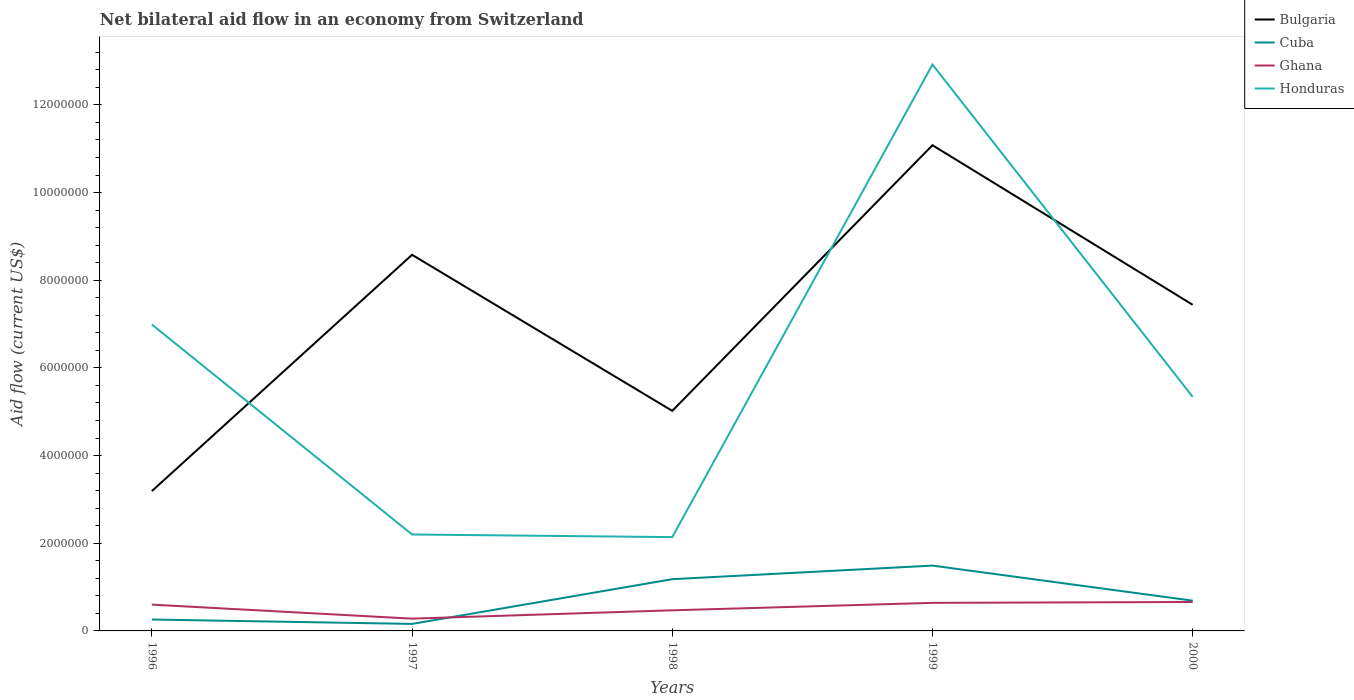How many different coloured lines are there?
Your response must be concise. 4. Does the line corresponding to Bulgaria intersect with the line corresponding to Ghana?
Provide a succinct answer. No. Is the number of lines equal to the number of legend labels?
Keep it short and to the point. Yes. Across all years, what is the maximum net bilateral aid flow in Honduras?
Provide a succinct answer. 2.14e+06. In which year was the net bilateral aid flow in Ghana maximum?
Provide a short and direct response. 1997. What is the total net bilateral aid flow in Cuba in the graph?
Offer a very short reply. -4.30e+05. What is the difference between the highest and the second highest net bilateral aid flow in Cuba?
Keep it short and to the point. 1.33e+06. What is the difference between the highest and the lowest net bilateral aid flow in Cuba?
Make the answer very short. 2. How many lines are there?
Make the answer very short. 4. How many years are there in the graph?
Your response must be concise. 5. Are the values on the major ticks of Y-axis written in scientific E-notation?
Offer a very short reply. No. Does the graph contain any zero values?
Your answer should be very brief. No. Where does the legend appear in the graph?
Your response must be concise. Top right. How are the legend labels stacked?
Make the answer very short. Vertical. What is the title of the graph?
Offer a very short reply. Net bilateral aid flow in an economy from Switzerland. What is the label or title of the X-axis?
Your response must be concise. Years. What is the label or title of the Y-axis?
Make the answer very short. Aid flow (current US$). What is the Aid flow (current US$) in Bulgaria in 1996?
Offer a terse response. 3.19e+06. What is the Aid flow (current US$) in Cuba in 1996?
Provide a short and direct response. 2.60e+05. What is the Aid flow (current US$) of Honduras in 1996?
Keep it short and to the point. 6.99e+06. What is the Aid flow (current US$) of Bulgaria in 1997?
Your answer should be compact. 8.58e+06. What is the Aid flow (current US$) in Ghana in 1997?
Offer a terse response. 2.80e+05. What is the Aid flow (current US$) of Honduras in 1997?
Your answer should be very brief. 2.20e+06. What is the Aid flow (current US$) in Bulgaria in 1998?
Your answer should be compact. 5.02e+06. What is the Aid flow (current US$) in Cuba in 1998?
Your response must be concise. 1.18e+06. What is the Aid flow (current US$) of Honduras in 1998?
Your answer should be compact. 2.14e+06. What is the Aid flow (current US$) of Bulgaria in 1999?
Provide a succinct answer. 1.11e+07. What is the Aid flow (current US$) in Cuba in 1999?
Your response must be concise. 1.49e+06. What is the Aid flow (current US$) in Ghana in 1999?
Keep it short and to the point. 6.40e+05. What is the Aid flow (current US$) of Honduras in 1999?
Keep it short and to the point. 1.29e+07. What is the Aid flow (current US$) in Bulgaria in 2000?
Give a very brief answer. 7.44e+06. What is the Aid flow (current US$) in Cuba in 2000?
Your answer should be compact. 6.90e+05. What is the Aid flow (current US$) of Honduras in 2000?
Offer a very short reply. 5.34e+06. Across all years, what is the maximum Aid flow (current US$) of Bulgaria?
Provide a succinct answer. 1.11e+07. Across all years, what is the maximum Aid flow (current US$) of Cuba?
Your response must be concise. 1.49e+06. Across all years, what is the maximum Aid flow (current US$) in Honduras?
Provide a succinct answer. 1.29e+07. Across all years, what is the minimum Aid flow (current US$) of Bulgaria?
Your answer should be compact. 3.19e+06. Across all years, what is the minimum Aid flow (current US$) in Cuba?
Provide a short and direct response. 1.60e+05. Across all years, what is the minimum Aid flow (current US$) of Ghana?
Provide a short and direct response. 2.80e+05. Across all years, what is the minimum Aid flow (current US$) of Honduras?
Your answer should be compact. 2.14e+06. What is the total Aid flow (current US$) in Bulgaria in the graph?
Keep it short and to the point. 3.53e+07. What is the total Aid flow (current US$) in Cuba in the graph?
Your answer should be very brief. 3.78e+06. What is the total Aid flow (current US$) of Ghana in the graph?
Ensure brevity in your answer.  2.65e+06. What is the total Aid flow (current US$) in Honduras in the graph?
Offer a terse response. 2.96e+07. What is the difference between the Aid flow (current US$) of Bulgaria in 1996 and that in 1997?
Ensure brevity in your answer.  -5.39e+06. What is the difference between the Aid flow (current US$) in Ghana in 1996 and that in 1997?
Offer a terse response. 3.20e+05. What is the difference between the Aid flow (current US$) in Honduras in 1996 and that in 1997?
Your answer should be very brief. 4.79e+06. What is the difference between the Aid flow (current US$) of Bulgaria in 1996 and that in 1998?
Keep it short and to the point. -1.83e+06. What is the difference between the Aid flow (current US$) in Cuba in 1996 and that in 1998?
Your response must be concise. -9.20e+05. What is the difference between the Aid flow (current US$) of Ghana in 1996 and that in 1998?
Offer a terse response. 1.30e+05. What is the difference between the Aid flow (current US$) of Honduras in 1996 and that in 1998?
Offer a very short reply. 4.85e+06. What is the difference between the Aid flow (current US$) in Bulgaria in 1996 and that in 1999?
Provide a short and direct response. -7.89e+06. What is the difference between the Aid flow (current US$) of Cuba in 1996 and that in 1999?
Your response must be concise. -1.23e+06. What is the difference between the Aid flow (current US$) in Ghana in 1996 and that in 1999?
Your response must be concise. -4.00e+04. What is the difference between the Aid flow (current US$) of Honduras in 1996 and that in 1999?
Offer a terse response. -5.93e+06. What is the difference between the Aid flow (current US$) in Bulgaria in 1996 and that in 2000?
Ensure brevity in your answer.  -4.25e+06. What is the difference between the Aid flow (current US$) of Cuba in 1996 and that in 2000?
Your answer should be compact. -4.30e+05. What is the difference between the Aid flow (current US$) in Honduras in 1996 and that in 2000?
Give a very brief answer. 1.65e+06. What is the difference between the Aid flow (current US$) in Bulgaria in 1997 and that in 1998?
Ensure brevity in your answer.  3.56e+06. What is the difference between the Aid flow (current US$) in Cuba in 1997 and that in 1998?
Offer a terse response. -1.02e+06. What is the difference between the Aid flow (current US$) of Ghana in 1997 and that in 1998?
Provide a succinct answer. -1.90e+05. What is the difference between the Aid flow (current US$) in Bulgaria in 1997 and that in 1999?
Make the answer very short. -2.50e+06. What is the difference between the Aid flow (current US$) in Cuba in 1997 and that in 1999?
Your answer should be compact. -1.33e+06. What is the difference between the Aid flow (current US$) in Ghana in 1997 and that in 1999?
Keep it short and to the point. -3.60e+05. What is the difference between the Aid flow (current US$) of Honduras in 1997 and that in 1999?
Keep it short and to the point. -1.07e+07. What is the difference between the Aid flow (current US$) of Bulgaria in 1997 and that in 2000?
Keep it short and to the point. 1.14e+06. What is the difference between the Aid flow (current US$) in Cuba in 1997 and that in 2000?
Give a very brief answer. -5.30e+05. What is the difference between the Aid flow (current US$) of Ghana in 1997 and that in 2000?
Your response must be concise. -3.80e+05. What is the difference between the Aid flow (current US$) of Honduras in 1997 and that in 2000?
Your answer should be very brief. -3.14e+06. What is the difference between the Aid flow (current US$) of Bulgaria in 1998 and that in 1999?
Your answer should be very brief. -6.06e+06. What is the difference between the Aid flow (current US$) of Cuba in 1998 and that in 1999?
Ensure brevity in your answer.  -3.10e+05. What is the difference between the Aid flow (current US$) of Honduras in 1998 and that in 1999?
Your answer should be compact. -1.08e+07. What is the difference between the Aid flow (current US$) of Bulgaria in 1998 and that in 2000?
Your answer should be very brief. -2.42e+06. What is the difference between the Aid flow (current US$) of Honduras in 1998 and that in 2000?
Keep it short and to the point. -3.20e+06. What is the difference between the Aid flow (current US$) of Bulgaria in 1999 and that in 2000?
Offer a terse response. 3.64e+06. What is the difference between the Aid flow (current US$) of Ghana in 1999 and that in 2000?
Provide a short and direct response. -2.00e+04. What is the difference between the Aid flow (current US$) in Honduras in 1999 and that in 2000?
Provide a succinct answer. 7.58e+06. What is the difference between the Aid flow (current US$) of Bulgaria in 1996 and the Aid flow (current US$) of Cuba in 1997?
Provide a short and direct response. 3.03e+06. What is the difference between the Aid flow (current US$) of Bulgaria in 1996 and the Aid flow (current US$) of Ghana in 1997?
Make the answer very short. 2.91e+06. What is the difference between the Aid flow (current US$) in Bulgaria in 1996 and the Aid flow (current US$) in Honduras in 1997?
Your answer should be very brief. 9.90e+05. What is the difference between the Aid flow (current US$) in Cuba in 1996 and the Aid flow (current US$) in Ghana in 1997?
Provide a succinct answer. -2.00e+04. What is the difference between the Aid flow (current US$) in Cuba in 1996 and the Aid flow (current US$) in Honduras in 1997?
Make the answer very short. -1.94e+06. What is the difference between the Aid flow (current US$) of Ghana in 1996 and the Aid flow (current US$) of Honduras in 1997?
Ensure brevity in your answer.  -1.60e+06. What is the difference between the Aid flow (current US$) in Bulgaria in 1996 and the Aid flow (current US$) in Cuba in 1998?
Keep it short and to the point. 2.01e+06. What is the difference between the Aid flow (current US$) in Bulgaria in 1996 and the Aid flow (current US$) in Ghana in 1998?
Your answer should be compact. 2.72e+06. What is the difference between the Aid flow (current US$) of Bulgaria in 1996 and the Aid flow (current US$) of Honduras in 1998?
Your answer should be very brief. 1.05e+06. What is the difference between the Aid flow (current US$) of Cuba in 1996 and the Aid flow (current US$) of Ghana in 1998?
Provide a succinct answer. -2.10e+05. What is the difference between the Aid flow (current US$) of Cuba in 1996 and the Aid flow (current US$) of Honduras in 1998?
Offer a terse response. -1.88e+06. What is the difference between the Aid flow (current US$) of Ghana in 1996 and the Aid flow (current US$) of Honduras in 1998?
Make the answer very short. -1.54e+06. What is the difference between the Aid flow (current US$) in Bulgaria in 1996 and the Aid flow (current US$) in Cuba in 1999?
Offer a very short reply. 1.70e+06. What is the difference between the Aid flow (current US$) of Bulgaria in 1996 and the Aid flow (current US$) of Ghana in 1999?
Provide a short and direct response. 2.55e+06. What is the difference between the Aid flow (current US$) of Bulgaria in 1996 and the Aid flow (current US$) of Honduras in 1999?
Your answer should be very brief. -9.73e+06. What is the difference between the Aid flow (current US$) in Cuba in 1996 and the Aid flow (current US$) in Ghana in 1999?
Your response must be concise. -3.80e+05. What is the difference between the Aid flow (current US$) of Cuba in 1996 and the Aid flow (current US$) of Honduras in 1999?
Provide a short and direct response. -1.27e+07. What is the difference between the Aid flow (current US$) of Ghana in 1996 and the Aid flow (current US$) of Honduras in 1999?
Offer a terse response. -1.23e+07. What is the difference between the Aid flow (current US$) of Bulgaria in 1996 and the Aid flow (current US$) of Cuba in 2000?
Your response must be concise. 2.50e+06. What is the difference between the Aid flow (current US$) in Bulgaria in 1996 and the Aid flow (current US$) in Ghana in 2000?
Offer a terse response. 2.53e+06. What is the difference between the Aid flow (current US$) in Bulgaria in 1996 and the Aid flow (current US$) in Honduras in 2000?
Provide a succinct answer. -2.15e+06. What is the difference between the Aid flow (current US$) of Cuba in 1996 and the Aid flow (current US$) of Ghana in 2000?
Provide a succinct answer. -4.00e+05. What is the difference between the Aid flow (current US$) of Cuba in 1996 and the Aid flow (current US$) of Honduras in 2000?
Give a very brief answer. -5.08e+06. What is the difference between the Aid flow (current US$) in Ghana in 1996 and the Aid flow (current US$) in Honduras in 2000?
Offer a terse response. -4.74e+06. What is the difference between the Aid flow (current US$) in Bulgaria in 1997 and the Aid flow (current US$) in Cuba in 1998?
Your answer should be compact. 7.40e+06. What is the difference between the Aid flow (current US$) of Bulgaria in 1997 and the Aid flow (current US$) of Ghana in 1998?
Give a very brief answer. 8.11e+06. What is the difference between the Aid flow (current US$) of Bulgaria in 1997 and the Aid flow (current US$) of Honduras in 1998?
Provide a succinct answer. 6.44e+06. What is the difference between the Aid flow (current US$) of Cuba in 1997 and the Aid flow (current US$) of Ghana in 1998?
Make the answer very short. -3.10e+05. What is the difference between the Aid flow (current US$) in Cuba in 1997 and the Aid flow (current US$) in Honduras in 1998?
Your response must be concise. -1.98e+06. What is the difference between the Aid flow (current US$) of Ghana in 1997 and the Aid flow (current US$) of Honduras in 1998?
Offer a terse response. -1.86e+06. What is the difference between the Aid flow (current US$) in Bulgaria in 1997 and the Aid flow (current US$) in Cuba in 1999?
Your answer should be compact. 7.09e+06. What is the difference between the Aid flow (current US$) in Bulgaria in 1997 and the Aid flow (current US$) in Ghana in 1999?
Ensure brevity in your answer.  7.94e+06. What is the difference between the Aid flow (current US$) in Bulgaria in 1997 and the Aid flow (current US$) in Honduras in 1999?
Give a very brief answer. -4.34e+06. What is the difference between the Aid flow (current US$) of Cuba in 1997 and the Aid flow (current US$) of Ghana in 1999?
Your answer should be very brief. -4.80e+05. What is the difference between the Aid flow (current US$) of Cuba in 1997 and the Aid flow (current US$) of Honduras in 1999?
Offer a very short reply. -1.28e+07. What is the difference between the Aid flow (current US$) in Ghana in 1997 and the Aid flow (current US$) in Honduras in 1999?
Provide a short and direct response. -1.26e+07. What is the difference between the Aid flow (current US$) of Bulgaria in 1997 and the Aid flow (current US$) of Cuba in 2000?
Ensure brevity in your answer.  7.89e+06. What is the difference between the Aid flow (current US$) of Bulgaria in 1997 and the Aid flow (current US$) of Ghana in 2000?
Offer a very short reply. 7.92e+06. What is the difference between the Aid flow (current US$) in Bulgaria in 1997 and the Aid flow (current US$) in Honduras in 2000?
Your answer should be very brief. 3.24e+06. What is the difference between the Aid flow (current US$) in Cuba in 1997 and the Aid flow (current US$) in Ghana in 2000?
Your response must be concise. -5.00e+05. What is the difference between the Aid flow (current US$) of Cuba in 1997 and the Aid flow (current US$) of Honduras in 2000?
Your response must be concise. -5.18e+06. What is the difference between the Aid flow (current US$) of Ghana in 1997 and the Aid flow (current US$) of Honduras in 2000?
Provide a succinct answer. -5.06e+06. What is the difference between the Aid flow (current US$) in Bulgaria in 1998 and the Aid flow (current US$) in Cuba in 1999?
Ensure brevity in your answer.  3.53e+06. What is the difference between the Aid flow (current US$) in Bulgaria in 1998 and the Aid flow (current US$) in Ghana in 1999?
Your answer should be compact. 4.38e+06. What is the difference between the Aid flow (current US$) of Bulgaria in 1998 and the Aid flow (current US$) of Honduras in 1999?
Your answer should be compact. -7.90e+06. What is the difference between the Aid flow (current US$) of Cuba in 1998 and the Aid flow (current US$) of Ghana in 1999?
Your answer should be compact. 5.40e+05. What is the difference between the Aid flow (current US$) of Cuba in 1998 and the Aid flow (current US$) of Honduras in 1999?
Make the answer very short. -1.17e+07. What is the difference between the Aid flow (current US$) of Ghana in 1998 and the Aid flow (current US$) of Honduras in 1999?
Your response must be concise. -1.24e+07. What is the difference between the Aid flow (current US$) of Bulgaria in 1998 and the Aid flow (current US$) of Cuba in 2000?
Your answer should be very brief. 4.33e+06. What is the difference between the Aid flow (current US$) in Bulgaria in 1998 and the Aid flow (current US$) in Ghana in 2000?
Provide a short and direct response. 4.36e+06. What is the difference between the Aid flow (current US$) in Bulgaria in 1998 and the Aid flow (current US$) in Honduras in 2000?
Offer a terse response. -3.20e+05. What is the difference between the Aid flow (current US$) of Cuba in 1998 and the Aid flow (current US$) of Ghana in 2000?
Your answer should be very brief. 5.20e+05. What is the difference between the Aid flow (current US$) in Cuba in 1998 and the Aid flow (current US$) in Honduras in 2000?
Provide a short and direct response. -4.16e+06. What is the difference between the Aid flow (current US$) in Ghana in 1998 and the Aid flow (current US$) in Honduras in 2000?
Give a very brief answer. -4.87e+06. What is the difference between the Aid flow (current US$) in Bulgaria in 1999 and the Aid flow (current US$) in Cuba in 2000?
Keep it short and to the point. 1.04e+07. What is the difference between the Aid flow (current US$) of Bulgaria in 1999 and the Aid flow (current US$) of Ghana in 2000?
Make the answer very short. 1.04e+07. What is the difference between the Aid flow (current US$) in Bulgaria in 1999 and the Aid flow (current US$) in Honduras in 2000?
Provide a succinct answer. 5.74e+06. What is the difference between the Aid flow (current US$) in Cuba in 1999 and the Aid flow (current US$) in Ghana in 2000?
Provide a succinct answer. 8.30e+05. What is the difference between the Aid flow (current US$) of Cuba in 1999 and the Aid flow (current US$) of Honduras in 2000?
Keep it short and to the point. -3.85e+06. What is the difference between the Aid flow (current US$) of Ghana in 1999 and the Aid flow (current US$) of Honduras in 2000?
Provide a short and direct response. -4.70e+06. What is the average Aid flow (current US$) of Bulgaria per year?
Provide a short and direct response. 7.06e+06. What is the average Aid flow (current US$) in Cuba per year?
Your answer should be compact. 7.56e+05. What is the average Aid flow (current US$) in Ghana per year?
Your answer should be very brief. 5.30e+05. What is the average Aid flow (current US$) in Honduras per year?
Keep it short and to the point. 5.92e+06. In the year 1996, what is the difference between the Aid flow (current US$) in Bulgaria and Aid flow (current US$) in Cuba?
Make the answer very short. 2.93e+06. In the year 1996, what is the difference between the Aid flow (current US$) in Bulgaria and Aid flow (current US$) in Ghana?
Ensure brevity in your answer.  2.59e+06. In the year 1996, what is the difference between the Aid flow (current US$) in Bulgaria and Aid flow (current US$) in Honduras?
Your answer should be very brief. -3.80e+06. In the year 1996, what is the difference between the Aid flow (current US$) in Cuba and Aid flow (current US$) in Ghana?
Ensure brevity in your answer.  -3.40e+05. In the year 1996, what is the difference between the Aid flow (current US$) of Cuba and Aid flow (current US$) of Honduras?
Offer a very short reply. -6.73e+06. In the year 1996, what is the difference between the Aid flow (current US$) of Ghana and Aid flow (current US$) of Honduras?
Offer a terse response. -6.39e+06. In the year 1997, what is the difference between the Aid flow (current US$) in Bulgaria and Aid flow (current US$) in Cuba?
Keep it short and to the point. 8.42e+06. In the year 1997, what is the difference between the Aid flow (current US$) of Bulgaria and Aid flow (current US$) of Ghana?
Provide a short and direct response. 8.30e+06. In the year 1997, what is the difference between the Aid flow (current US$) in Bulgaria and Aid flow (current US$) in Honduras?
Your response must be concise. 6.38e+06. In the year 1997, what is the difference between the Aid flow (current US$) of Cuba and Aid flow (current US$) of Ghana?
Your answer should be very brief. -1.20e+05. In the year 1997, what is the difference between the Aid flow (current US$) of Cuba and Aid flow (current US$) of Honduras?
Your answer should be compact. -2.04e+06. In the year 1997, what is the difference between the Aid flow (current US$) in Ghana and Aid flow (current US$) in Honduras?
Provide a succinct answer. -1.92e+06. In the year 1998, what is the difference between the Aid flow (current US$) of Bulgaria and Aid flow (current US$) of Cuba?
Make the answer very short. 3.84e+06. In the year 1998, what is the difference between the Aid flow (current US$) of Bulgaria and Aid flow (current US$) of Ghana?
Offer a terse response. 4.55e+06. In the year 1998, what is the difference between the Aid flow (current US$) of Bulgaria and Aid flow (current US$) of Honduras?
Keep it short and to the point. 2.88e+06. In the year 1998, what is the difference between the Aid flow (current US$) of Cuba and Aid flow (current US$) of Ghana?
Give a very brief answer. 7.10e+05. In the year 1998, what is the difference between the Aid flow (current US$) of Cuba and Aid flow (current US$) of Honduras?
Your answer should be very brief. -9.60e+05. In the year 1998, what is the difference between the Aid flow (current US$) in Ghana and Aid flow (current US$) in Honduras?
Make the answer very short. -1.67e+06. In the year 1999, what is the difference between the Aid flow (current US$) in Bulgaria and Aid flow (current US$) in Cuba?
Your answer should be very brief. 9.59e+06. In the year 1999, what is the difference between the Aid flow (current US$) in Bulgaria and Aid flow (current US$) in Ghana?
Offer a very short reply. 1.04e+07. In the year 1999, what is the difference between the Aid flow (current US$) in Bulgaria and Aid flow (current US$) in Honduras?
Your answer should be compact. -1.84e+06. In the year 1999, what is the difference between the Aid flow (current US$) in Cuba and Aid flow (current US$) in Ghana?
Provide a succinct answer. 8.50e+05. In the year 1999, what is the difference between the Aid flow (current US$) in Cuba and Aid flow (current US$) in Honduras?
Provide a short and direct response. -1.14e+07. In the year 1999, what is the difference between the Aid flow (current US$) of Ghana and Aid flow (current US$) of Honduras?
Your response must be concise. -1.23e+07. In the year 2000, what is the difference between the Aid flow (current US$) in Bulgaria and Aid flow (current US$) in Cuba?
Your answer should be compact. 6.75e+06. In the year 2000, what is the difference between the Aid flow (current US$) of Bulgaria and Aid flow (current US$) of Ghana?
Provide a succinct answer. 6.78e+06. In the year 2000, what is the difference between the Aid flow (current US$) of Bulgaria and Aid flow (current US$) of Honduras?
Your response must be concise. 2.10e+06. In the year 2000, what is the difference between the Aid flow (current US$) in Cuba and Aid flow (current US$) in Honduras?
Provide a short and direct response. -4.65e+06. In the year 2000, what is the difference between the Aid flow (current US$) in Ghana and Aid flow (current US$) in Honduras?
Make the answer very short. -4.68e+06. What is the ratio of the Aid flow (current US$) of Bulgaria in 1996 to that in 1997?
Your response must be concise. 0.37. What is the ratio of the Aid flow (current US$) in Cuba in 1996 to that in 1997?
Keep it short and to the point. 1.62. What is the ratio of the Aid flow (current US$) in Ghana in 1996 to that in 1997?
Make the answer very short. 2.14. What is the ratio of the Aid flow (current US$) of Honduras in 1996 to that in 1997?
Offer a very short reply. 3.18. What is the ratio of the Aid flow (current US$) in Bulgaria in 1996 to that in 1998?
Offer a very short reply. 0.64. What is the ratio of the Aid flow (current US$) of Cuba in 1996 to that in 1998?
Your response must be concise. 0.22. What is the ratio of the Aid flow (current US$) of Ghana in 1996 to that in 1998?
Provide a short and direct response. 1.28. What is the ratio of the Aid flow (current US$) in Honduras in 1996 to that in 1998?
Provide a succinct answer. 3.27. What is the ratio of the Aid flow (current US$) of Bulgaria in 1996 to that in 1999?
Ensure brevity in your answer.  0.29. What is the ratio of the Aid flow (current US$) of Cuba in 1996 to that in 1999?
Ensure brevity in your answer.  0.17. What is the ratio of the Aid flow (current US$) of Ghana in 1996 to that in 1999?
Provide a succinct answer. 0.94. What is the ratio of the Aid flow (current US$) of Honduras in 1996 to that in 1999?
Offer a terse response. 0.54. What is the ratio of the Aid flow (current US$) of Bulgaria in 1996 to that in 2000?
Provide a short and direct response. 0.43. What is the ratio of the Aid flow (current US$) in Cuba in 1996 to that in 2000?
Your answer should be compact. 0.38. What is the ratio of the Aid flow (current US$) in Ghana in 1996 to that in 2000?
Provide a succinct answer. 0.91. What is the ratio of the Aid flow (current US$) of Honduras in 1996 to that in 2000?
Give a very brief answer. 1.31. What is the ratio of the Aid flow (current US$) of Bulgaria in 1997 to that in 1998?
Your response must be concise. 1.71. What is the ratio of the Aid flow (current US$) of Cuba in 1997 to that in 1998?
Make the answer very short. 0.14. What is the ratio of the Aid flow (current US$) of Ghana in 1997 to that in 1998?
Provide a short and direct response. 0.6. What is the ratio of the Aid flow (current US$) of Honduras in 1997 to that in 1998?
Keep it short and to the point. 1.03. What is the ratio of the Aid flow (current US$) of Bulgaria in 1997 to that in 1999?
Your answer should be very brief. 0.77. What is the ratio of the Aid flow (current US$) of Cuba in 1997 to that in 1999?
Offer a terse response. 0.11. What is the ratio of the Aid flow (current US$) of Ghana in 1997 to that in 1999?
Offer a terse response. 0.44. What is the ratio of the Aid flow (current US$) of Honduras in 1997 to that in 1999?
Ensure brevity in your answer.  0.17. What is the ratio of the Aid flow (current US$) in Bulgaria in 1997 to that in 2000?
Ensure brevity in your answer.  1.15. What is the ratio of the Aid flow (current US$) of Cuba in 1997 to that in 2000?
Ensure brevity in your answer.  0.23. What is the ratio of the Aid flow (current US$) of Ghana in 1997 to that in 2000?
Your response must be concise. 0.42. What is the ratio of the Aid flow (current US$) in Honduras in 1997 to that in 2000?
Ensure brevity in your answer.  0.41. What is the ratio of the Aid flow (current US$) in Bulgaria in 1998 to that in 1999?
Provide a succinct answer. 0.45. What is the ratio of the Aid flow (current US$) of Cuba in 1998 to that in 1999?
Provide a succinct answer. 0.79. What is the ratio of the Aid flow (current US$) of Ghana in 1998 to that in 1999?
Provide a succinct answer. 0.73. What is the ratio of the Aid flow (current US$) in Honduras in 1998 to that in 1999?
Make the answer very short. 0.17. What is the ratio of the Aid flow (current US$) in Bulgaria in 1998 to that in 2000?
Make the answer very short. 0.67. What is the ratio of the Aid flow (current US$) in Cuba in 1998 to that in 2000?
Keep it short and to the point. 1.71. What is the ratio of the Aid flow (current US$) of Ghana in 1998 to that in 2000?
Ensure brevity in your answer.  0.71. What is the ratio of the Aid flow (current US$) of Honduras in 1998 to that in 2000?
Give a very brief answer. 0.4. What is the ratio of the Aid flow (current US$) of Bulgaria in 1999 to that in 2000?
Offer a very short reply. 1.49. What is the ratio of the Aid flow (current US$) of Cuba in 1999 to that in 2000?
Your response must be concise. 2.16. What is the ratio of the Aid flow (current US$) of Ghana in 1999 to that in 2000?
Your response must be concise. 0.97. What is the ratio of the Aid flow (current US$) of Honduras in 1999 to that in 2000?
Offer a very short reply. 2.42. What is the difference between the highest and the second highest Aid flow (current US$) in Bulgaria?
Provide a succinct answer. 2.50e+06. What is the difference between the highest and the second highest Aid flow (current US$) in Cuba?
Offer a very short reply. 3.10e+05. What is the difference between the highest and the second highest Aid flow (current US$) of Honduras?
Ensure brevity in your answer.  5.93e+06. What is the difference between the highest and the lowest Aid flow (current US$) in Bulgaria?
Provide a succinct answer. 7.89e+06. What is the difference between the highest and the lowest Aid flow (current US$) in Cuba?
Give a very brief answer. 1.33e+06. What is the difference between the highest and the lowest Aid flow (current US$) of Ghana?
Keep it short and to the point. 3.80e+05. What is the difference between the highest and the lowest Aid flow (current US$) of Honduras?
Keep it short and to the point. 1.08e+07. 